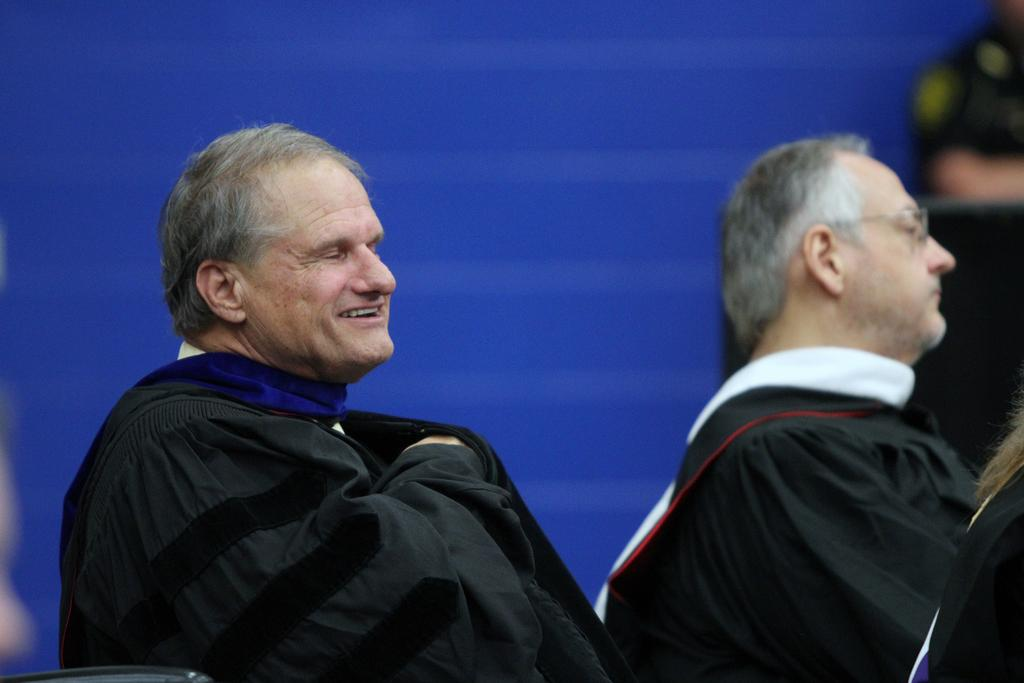Who is the main subject in the image? There is a man in the image. What is the man doing in the image? The man is sitting on a chair and smiling. Are there any other people in the image? Yes, there are people in front of the man. What is the color of the background in the image? The background of the image is blue. What is the weight of the chain that the man is holding in the image? There is no chain present in the image, so it is not possible to determine its weight. 